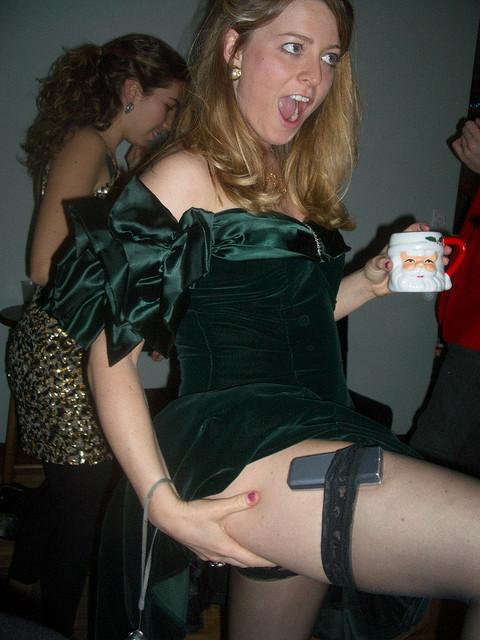What color is the girl's outfit?
Keep it brief. Green. What shape is the woman's ring?
Keep it brief. Round. What color is the woman's dress?
Write a very short answer. Green. What is on the girl's leg?
Write a very short answer. Cell phone. What is in her nylon?
Be succinct. Phone. 